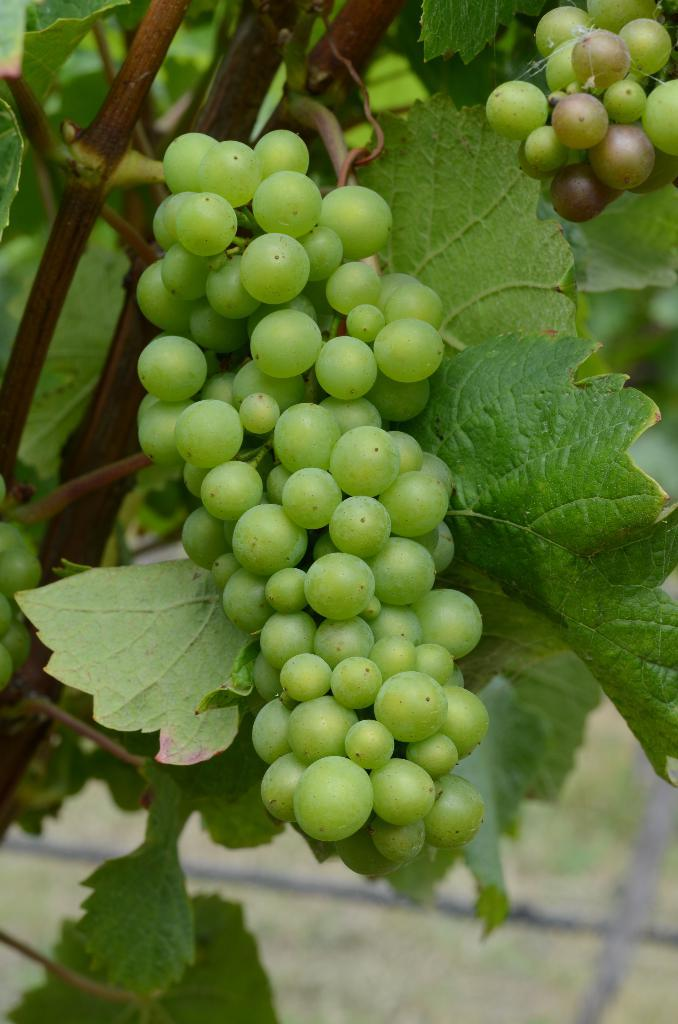What type of fruit is visible in the image? There is a bunch of grapes in the image. What else can be seen in the image besides the grapes? There are leaves in the image. What type of hose is being used to water the grapes in the image? There is no hose present in the image; it only shows a bunch of grapes and leaves. 